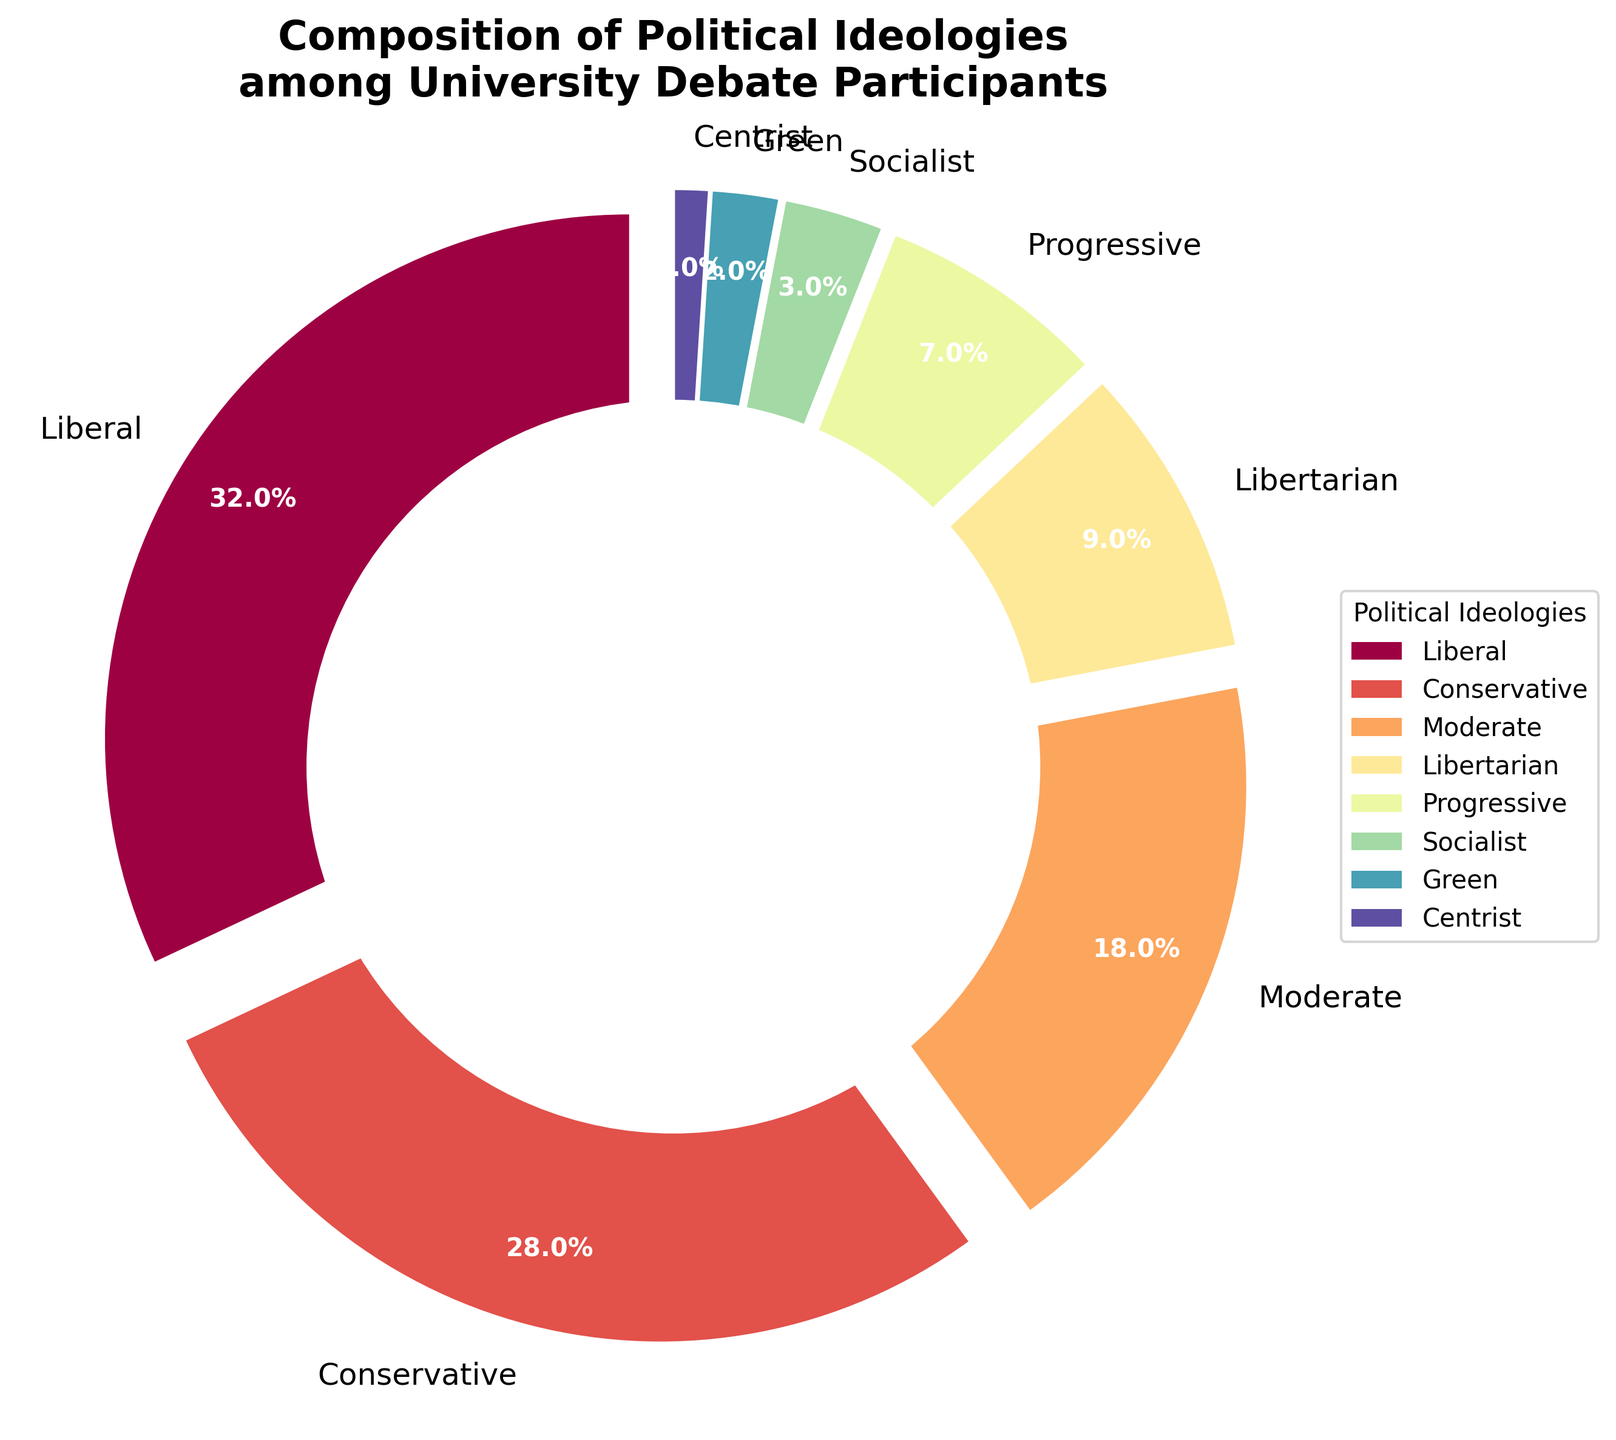Which political ideology holds the largest percentage among university debate participants? The pie chart shows that the slice labeled "Liberal" is the largest, indicating the highest percentage. This is confirmed by the percentage value in the chart.
Answer: Liberal Which two political ideologies have the smallest representation combined? The smallest slices in the pie chart are labeled "Green" and "Centrist", which have percentages of 2% and 1% respectively. Their combined representation is 2% + 1%.
Answer: Green and Centrist What is the difference in percentage between Liberals and Conservatives? The pie chart shows that Liberals hold 32% and Conservatives hold 28%. The difference is calculated by subtracting the smaller percentage from the larger one: 32% - 28%.
Answer: 4% Are Libertarians more or less represented than Progressives, and by how much? The pie chart indicates that Libertarians have 9% and Progressives have 7%. Since 9% is greater than 7%, Libertarians are more represented by a difference of 9% - 7%.
Answer: More by 2% What percentage of debate participants identify as either Moderate or Socialist? The pie chart shows that Moderates make up 18% and Socialists make up 3%. Adding these percentages together gives 18% + 3%.
Answer: 21% Which ideology occupies a larger section of the pie chart: Socialist or Green? Observing the pie chart, the slice labeled "Socialist" has a percentage of 3% while "Green" has 2%.
Answer: Socialist How many ideologies have a percentage greater than 10%? From the pie chart, it is visible that only two ideologies, Liberal (32%) and Conservative (28%), exceed 10%.
Answer: 2 If you add the percentages of Libertarian, Progressive, and Green, will they exceed the percentage of Moderates? The percentages are Libertarian (9%), Progressive (7%), and Green (2%). Adding them gives 9% + 7% + 2% = 18%. Since Moderates also hold 18%, the sum does not exceed Moderates.
Answer: No Which ideology is closest in percentage to Libertarians? The pie chart shows Libertarians at 9%, with the closest being Progressives at 7%.
Answer: Progressive What percentage of participants do not identify as either Liberal or Conservative? The pie chart shows Liberals at 32% and Conservatives at 28%, totaling 32% + 28% = 60%. Subtracting this from 100% gives 100% - 60%.
Answer: 40% 